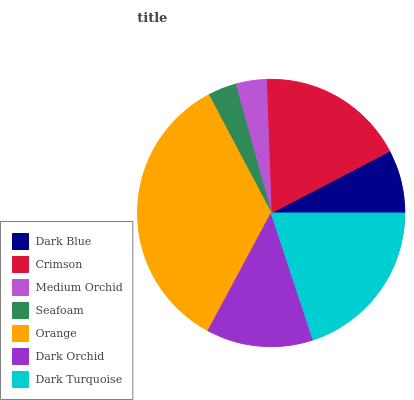Is Seafoam the minimum?
Answer yes or no. Yes. Is Orange the maximum?
Answer yes or no. Yes. Is Crimson the minimum?
Answer yes or no. No. Is Crimson the maximum?
Answer yes or no. No. Is Crimson greater than Dark Blue?
Answer yes or no. Yes. Is Dark Blue less than Crimson?
Answer yes or no. Yes. Is Dark Blue greater than Crimson?
Answer yes or no. No. Is Crimson less than Dark Blue?
Answer yes or no. No. Is Dark Orchid the high median?
Answer yes or no. Yes. Is Dark Orchid the low median?
Answer yes or no. Yes. Is Dark Blue the high median?
Answer yes or no. No. Is Medium Orchid the low median?
Answer yes or no. No. 